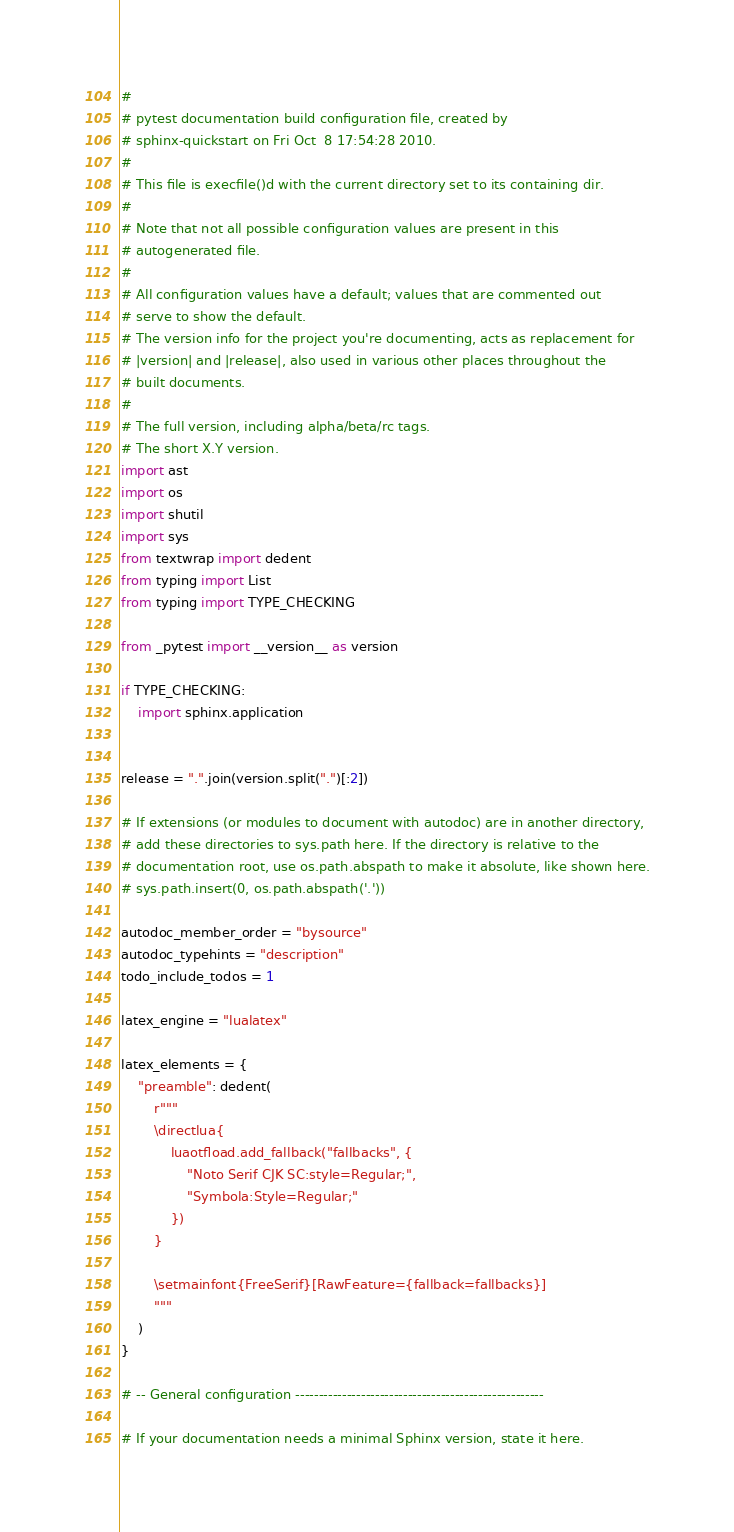<code> <loc_0><loc_0><loc_500><loc_500><_Python_>#
# pytest documentation build configuration file, created by
# sphinx-quickstart on Fri Oct  8 17:54:28 2010.
#
# This file is execfile()d with the current directory set to its containing dir.
#
# Note that not all possible configuration values are present in this
# autogenerated file.
#
# All configuration values have a default; values that are commented out
# serve to show the default.
# The version info for the project you're documenting, acts as replacement for
# |version| and |release|, also used in various other places throughout the
# built documents.
#
# The full version, including alpha/beta/rc tags.
# The short X.Y version.
import ast
import os
import shutil
import sys
from textwrap import dedent
from typing import List
from typing import TYPE_CHECKING

from _pytest import __version__ as version

if TYPE_CHECKING:
    import sphinx.application


release = ".".join(version.split(".")[:2])

# If extensions (or modules to document with autodoc) are in another directory,
# add these directories to sys.path here. If the directory is relative to the
# documentation root, use os.path.abspath to make it absolute, like shown here.
# sys.path.insert(0, os.path.abspath('.'))

autodoc_member_order = "bysource"
autodoc_typehints = "description"
todo_include_todos = 1

latex_engine = "lualatex"

latex_elements = {
    "preamble": dedent(
        r"""
        \directlua{
            luaotfload.add_fallback("fallbacks", {
                "Noto Serif CJK SC:style=Regular;",
                "Symbola:Style=Regular;"
            })
        }

        \setmainfont{FreeSerif}[RawFeature={fallback=fallbacks}]
        """
    )
}

# -- General configuration -----------------------------------------------------

# If your documentation needs a minimal Sphinx version, state it here.</code> 